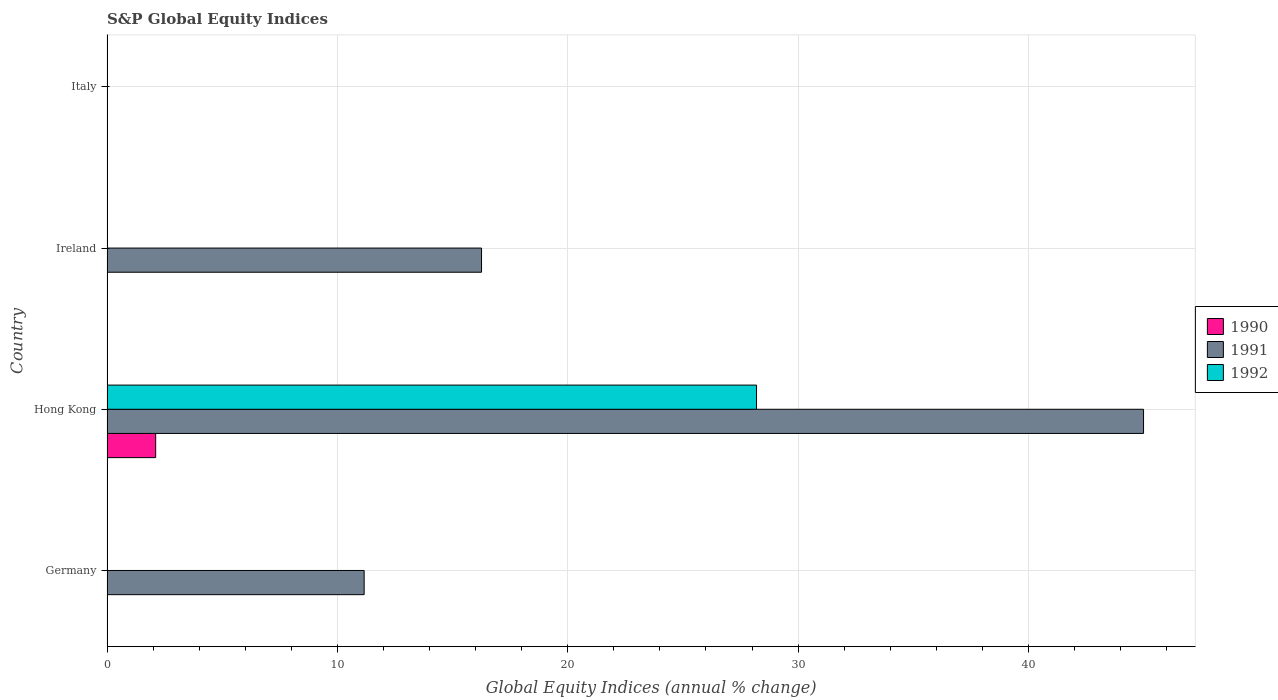Are the number of bars per tick equal to the number of legend labels?
Ensure brevity in your answer.  No. Are the number of bars on each tick of the Y-axis equal?
Give a very brief answer. No. How many bars are there on the 3rd tick from the top?
Provide a succinct answer. 3. How many bars are there on the 3rd tick from the bottom?
Offer a very short reply. 1. What is the label of the 2nd group of bars from the top?
Your response must be concise. Ireland. What is the global equity indices in 1992 in Hong Kong?
Your response must be concise. 28.19. Across all countries, what is the maximum global equity indices in 1992?
Make the answer very short. 28.19. Across all countries, what is the minimum global equity indices in 1990?
Your answer should be very brief. 0. In which country was the global equity indices in 1991 maximum?
Your answer should be compact. Hong Kong. What is the total global equity indices in 1991 in the graph?
Make the answer very short. 72.41. What is the difference between the global equity indices in 1991 in Hong Kong and that in Ireland?
Provide a succinct answer. 28.74. What is the difference between the global equity indices in 1992 in Italy and the global equity indices in 1991 in Hong Kong?
Give a very brief answer. -44.99. What is the average global equity indices in 1990 per country?
Make the answer very short. 0.53. What is the difference between the global equity indices in 1991 and global equity indices in 1992 in Hong Kong?
Ensure brevity in your answer.  16.8. What is the ratio of the global equity indices in 1991 in Germany to that in Ireland?
Offer a terse response. 0.69. What is the difference between the highest and the second highest global equity indices in 1991?
Provide a short and direct response. 28.74. What is the difference between the highest and the lowest global equity indices in 1992?
Offer a very short reply. 28.19. How many bars are there?
Provide a short and direct response. 5. How many countries are there in the graph?
Offer a terse response. 4. What is the difference between two consecutive major ticks on the X-axis?
Provide a short and direct response. 10. Are the values on the major ticks of X-axis written in scientific E-notation?
Your answer should be very brief. No. Does the graph contain any zero values?
Keep it short and to the point. Yes. Does the graph contain grids?
Provide a short and direct response. Yes. Where does the legend appear in the graph?
Your response must be concise. Center right. How many legend labels are there?
Keep it short and to the point. 3. How are the legend labels stacked?
Give a very brief answer. Vertical. What is the title of the graph?
Provide a short and direct response. S&P Global Equity Indices. Does "1965" appear as one of the legend labels in the graph?
Your answer should be very brief. No. What is the label or title of the X-axis?
Your answer should be very brief. Global Equity Indices (annual % change). What is the label or title of the Y-axis?
Your answer should be very brief. Country. What is the Global Equity Indices (annual % change) of 1990 in Germany?
Make the answer very short. 0. What is the Global Equity Indices (annual % change) of 1991 in Germany?
Ensure brevity in your answer.  11.16. What is the Global Equity Indices (annual % change) of 1992 in Germany?
Ensure brevity in your answer.  0. What is the Global Equity Indices (annual % change) in 1990 in Hong Kong?
Your answer should be compact. 2.11. What is the Global Equity Indices (annual % change) in 1991 in Hong Kong?
Keep it short and to the point. 44.99. What is the Global Equity Indices (annual % change) of 1992 in Hong Kong?
Provide a short and direct response. 28.19. What is the Global Equity Indices (annual % change) of 1991 in Ireland?
Give a very brief answer. 16.26. What is the Global Equity Indices (annual % change) in 1992 in Ireland?
Make the answer very short. 0. What is the Global Equity Indices (annual % change) of 1991 in Italy?
Ensure brevity in your answer.  0. What is the Global Equity Indices (annual % change) in 1992 in Italy?
Provide a succinct answer. 0. Across all countries, what is the maximum Global Equity Indices (annual % change) in 1990?
Your answer should be compact. 2.11. Across all countries, what is the maximum Global Equity Indices (annual % change) of 1991?
Keep it short and to the point. 44.99. Across all countries, what is the maximum Global Equity Indices (annual % change) of 1992?
Keep it short and to the point. 28.19. Across all countries, what is the minimum Global Equity Indices (annual % change) in 1990?
Offer a terse response. 0. Across all countries, what is the minimum Global Equity Indices (annual % change) in 1991?
Ensure brevity in your answer.  0. Across all countries, what is the minimum Global Equity Indices (annual % change) of 1992?
Give a very brief answer. 0. What is the total Global Equity Indices (annual % change) in 1990 in the graph?
Your response must be concise. 2.11. What is the total Global Equity Indices (annual % change) in 1991 in the graph?
Your answer should be compact. 72.41. What is the total Global Equity Indices (annual % change) in 1992 in the graph?
Make the answer very short. 28.19. What is the difference between the Global Equity Indices (annual % change) in 1991 in Germany and that in Hong Kong?
Keep it short and to the point. -33.83. What is the difference between the Global Equity Indices (annual % change) of 1991 in Germany and that in Ireland?
Keep it short and to the point. -5.09. What is the difference between the Global Equity Indices (annual % change) of 1991 in Hong Kong and that in Ireland?
Your answer should be very brief. 28.74. What is the difference between the Global Equity Indices (annual % change) in 1991 in Germany and the Global Equity Indices (annual % change) in 1992 in Hong Kong?
Your answer should be compact. -17.03. What is the difference between the Global Equity Indices (annual % change) of 1990 in Hong Kong and the Global Equity Indices (annual % change) of 1991 in Ireland?
Ensure brevity in your answer.  -14.14. What is the average Global Equity Indices (annual % change) in 1990 per country?
Ensure brevity in your answer.  0.53. What is the average Global Equity Indices (annual % change) of 1991 per country?
Your answer should be very brief. 18.1. What is the average Global Equity Indices (annual % change) of 1992 per country?
Provide a succinct answer. 7.05. What is the difference between the Global Equity Indices (annual % change) of 1990 and Global Equity Indices (annual % change) of 1991 in Hong Kong?
Offer a very short reply. -42.88. What is the difference between the Global Equity Indices (annual % change) in 1990 and Global Equity Indices (annual % change) in 1992 in Hong Kong?
Your answer should be compact. -26.08. What is the difference between the Global Equity Indices (annual % change) in 1991 and Global Equity Indices (annual % change) in 1992 in Hong Kong?
Your response must be concise. 16.8. What is the ratio of the Global Equity Indices (annual % change) of 1991 in Germany to that in Hong Kong?
Make the answer very short. 0.25. What is the ratio of the Global Equity Indices (annual % change) in 1991 in Germany to that in Ireland?
Your response must be concise. 0.69. What is the ratio of the Global Equity Indices (annual % change) of 1991 in Hong Kong to that in Ireland?
Provide a succinct answer. 2.77. What is the difference between the highest and the second highest Global Equity Indices (annual % change) in 1991?
Keep it short and to the point. 28.74. What is the difference between the highest and the lowest Global Equity Indices (annual % change) in 1990?
Your response must be concise. 2.11. What is the difference between the highest and the lowest Global Equity Indices (annual % change) in 1991?
Your response must be concise. 44.99. What is the difference between the highest and the lowest Global Equity Indices (annual % change) of 1992?
Make the answer very short. 28.19. 